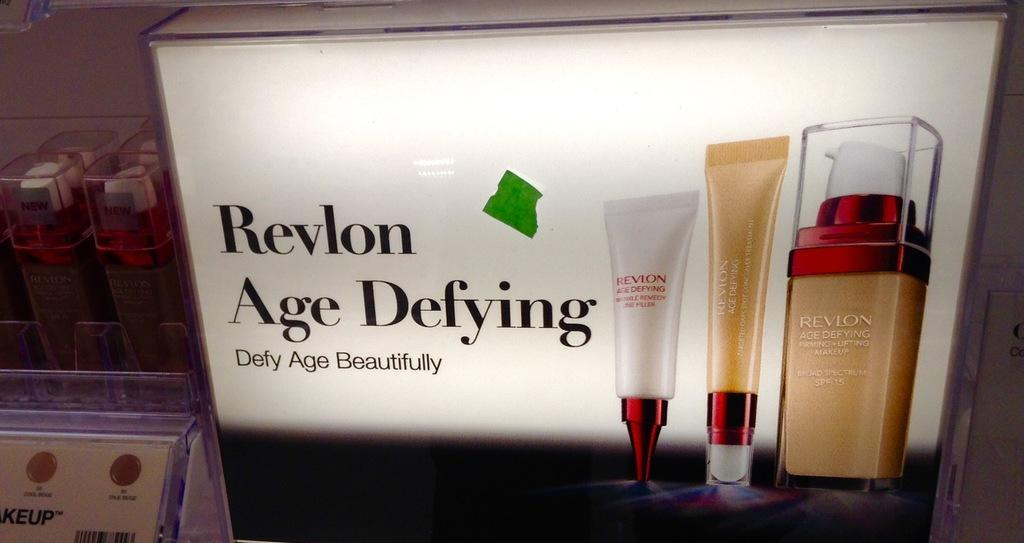Provide a one-sentence caption for the provided image. ad poster for revolon age defying makeup foundation. 